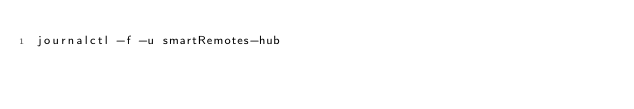<code> <loc_0><loc_0><loc_500><loc_500><_Bash_>journalctl -f -u smartRemotes-hub</code> 